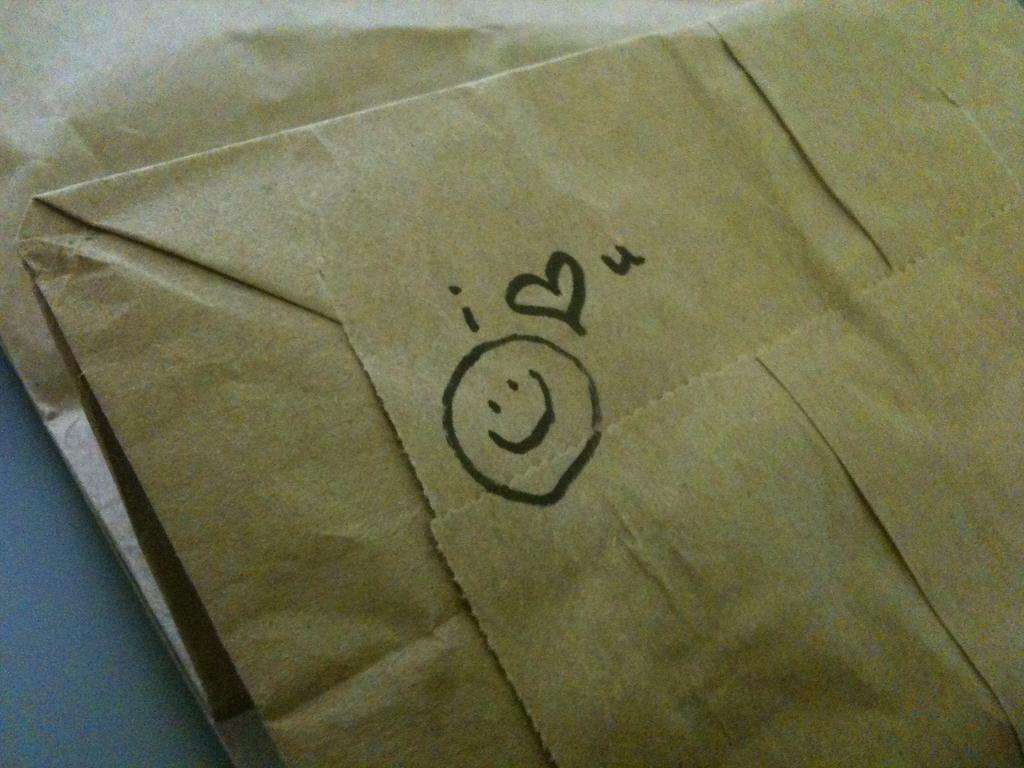<image>
Summarize the visual content of the image. A paper bag with a smiley face and "i <3 u" drawn on it. 